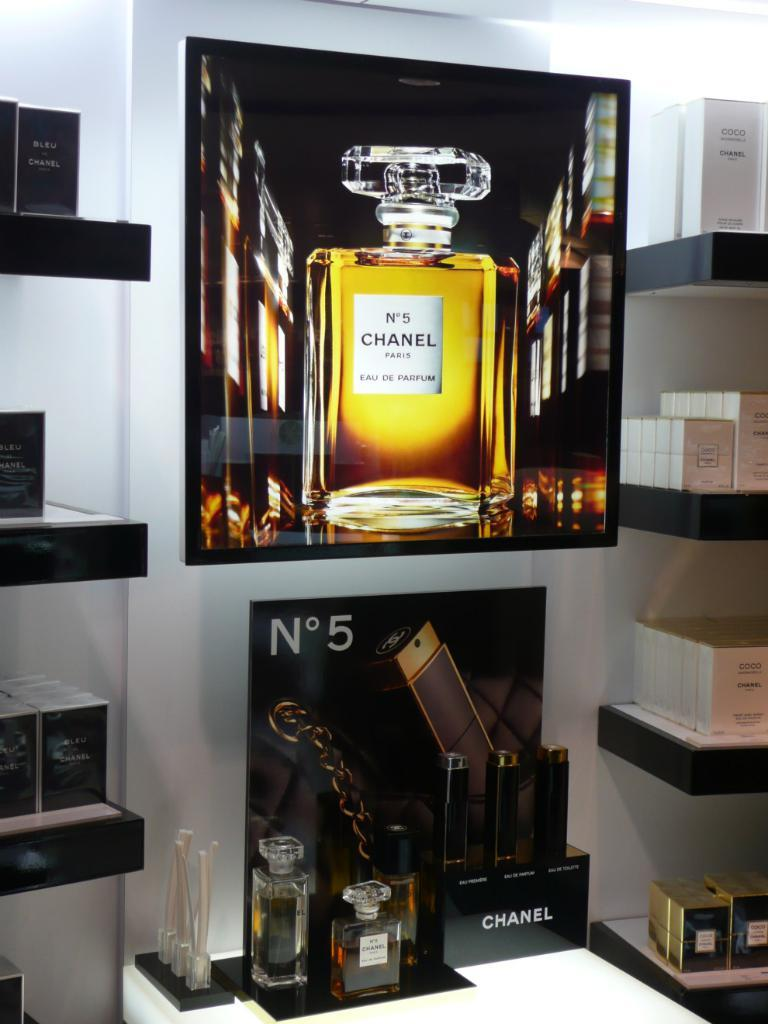<image>
Give a short and clear explanation of the subsequent image. A perfume display of Channel No. 5 and also shelves of various Channel perfumes. 